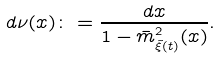<formula> <loc_0><loc_0><loc_500><loc_500>d \nu ( x ) \colon = \frac { d x } { 1 - \bar { m } ^ { 2 } _ { \tilde { \xi } ( t ) } ( x ) } .</formula> 